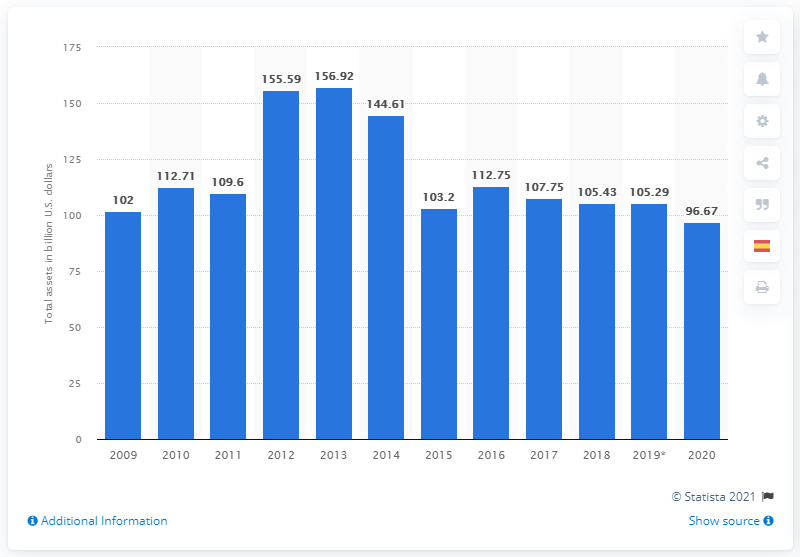List a handful of essential elements in this visual. Pemex's assets decreased by 96.67% in 2020. In 2020, Pemex's total assets were 96.67 dollars. 